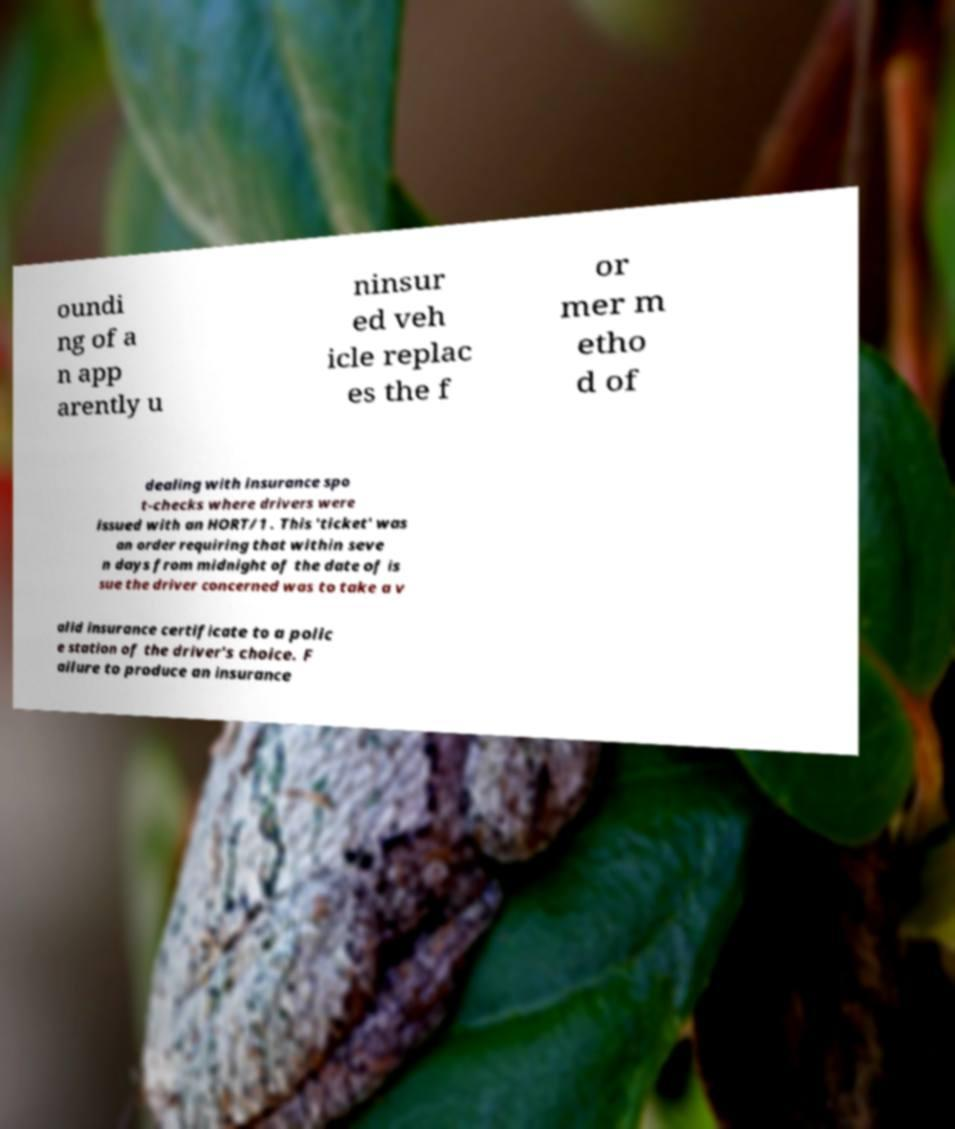Could you assist in decoding the text presented in this image and type it out clearly? oundi ng of a n app arently u ninsur ed veh icle replac es the f or mer m etho d of dealing with insurance spo t-checks where drivers were issued with an HORT/1 . This 'ticket' was an order requiring that within seve n days from midnight of the date of is sue the driver concerned was to take a v alid insurance certificate to a polic e station of the driver's choice. F ailure to produce an insurance 